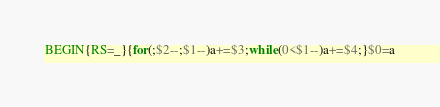Convert code to text. <code><loc_0><loc_0><loc_500><loc_500><_Awk_>BEGIN{RS=_}{for(;$2--;$1--)a+=$3;while(0<$1--)a+=$4;}$0=a</code> 